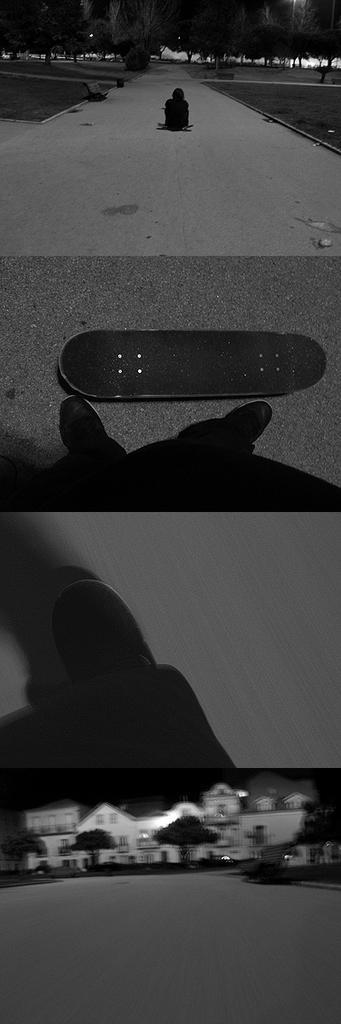In one or two sentences, can you explain what this image depicts? This picture is a collage of four images. In the first image we can observe a person sitting on the road and there are trees in the background. In the second image we can observe a skating board and a person on the road. In the third image we can observe a skating board moving on the road. In the fourth image we can observe houses and trees. 